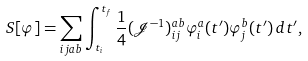Convert formula to latex. <formula><loc_0><loc_0><loc_500><loc_500>S [ \varphi ] = \sum _ { i j a b } \int _ { t _ { i } } ^ { t _ { f } } \frac { 1 } { 4 } ( \mathcal { J } ^ { - 1 } ) _ { i j } ^ { a b } \varphi ^ { a } _ { i } ( t ^ { \prime } ) \varphi ^ { b } _ { j } ( t ^ { \prime } ) \, d t ^ { \prime } ,</formula> 